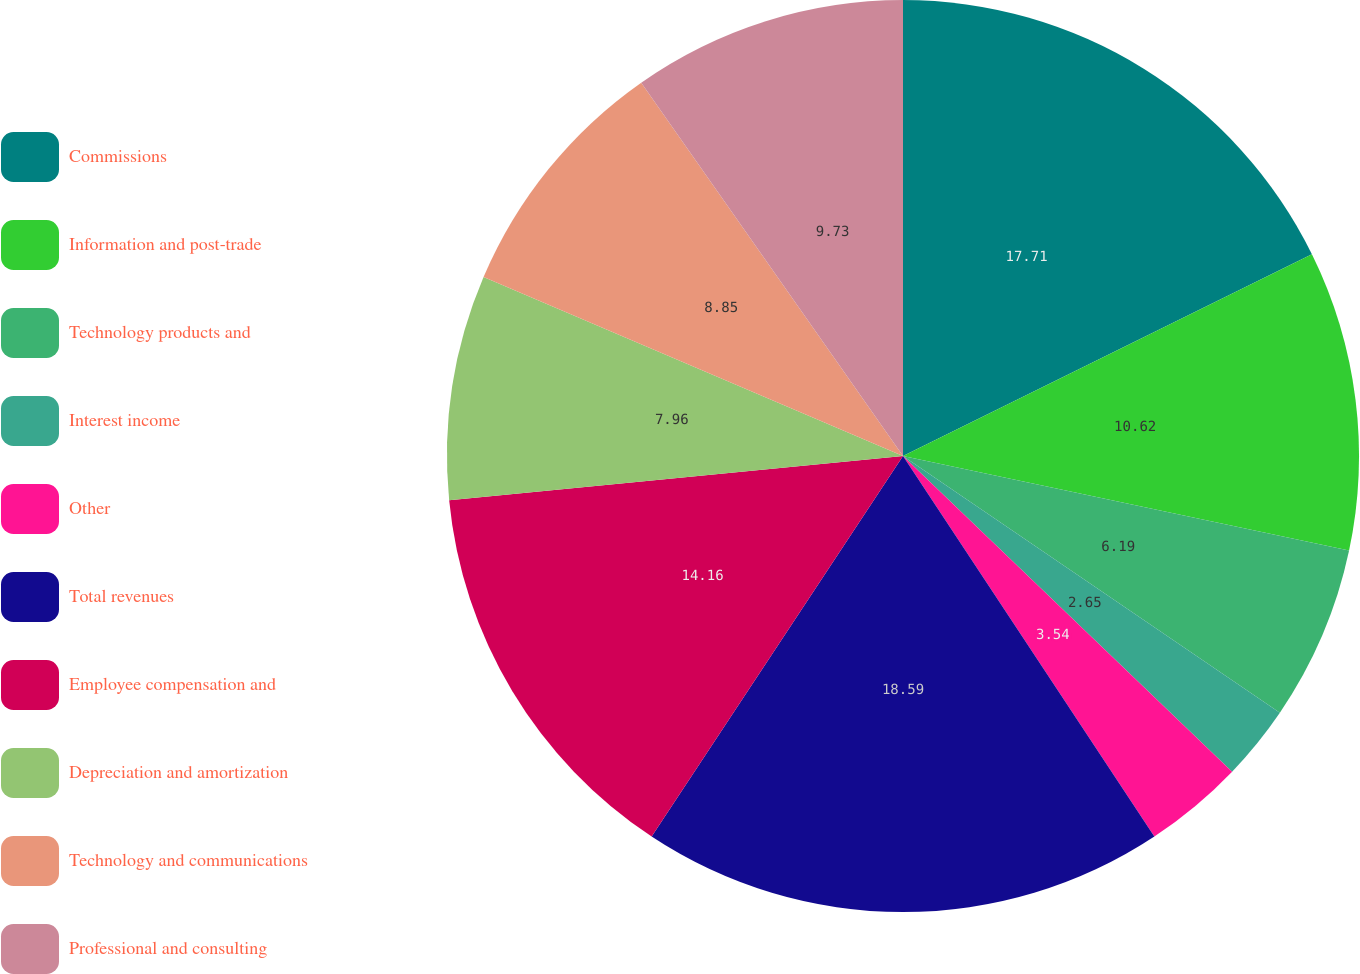Convert chart to OTSL. <chart><loc_0><loc_0><loc_500><loc_500><pie_chart><fcel>Commissions<fcel>Information and post-trade<fcel>Technology products and<fcel>Interest income<fcel>Other<fcel>Total revenues<fcel>Employee compensation and<fcel>Depreciation and amortization<fcel>Technology and communications<fcel>Professional and consulting<nl><fcel>17.7%<fcel>10.62%<fcel>6.19%<fcel>2.65%<fcel>3.54%<fcel>18.58%<fcel>14.16%<fcel>7.96%<fcel>8.85%<fcel>9.73%<nl></chart> 